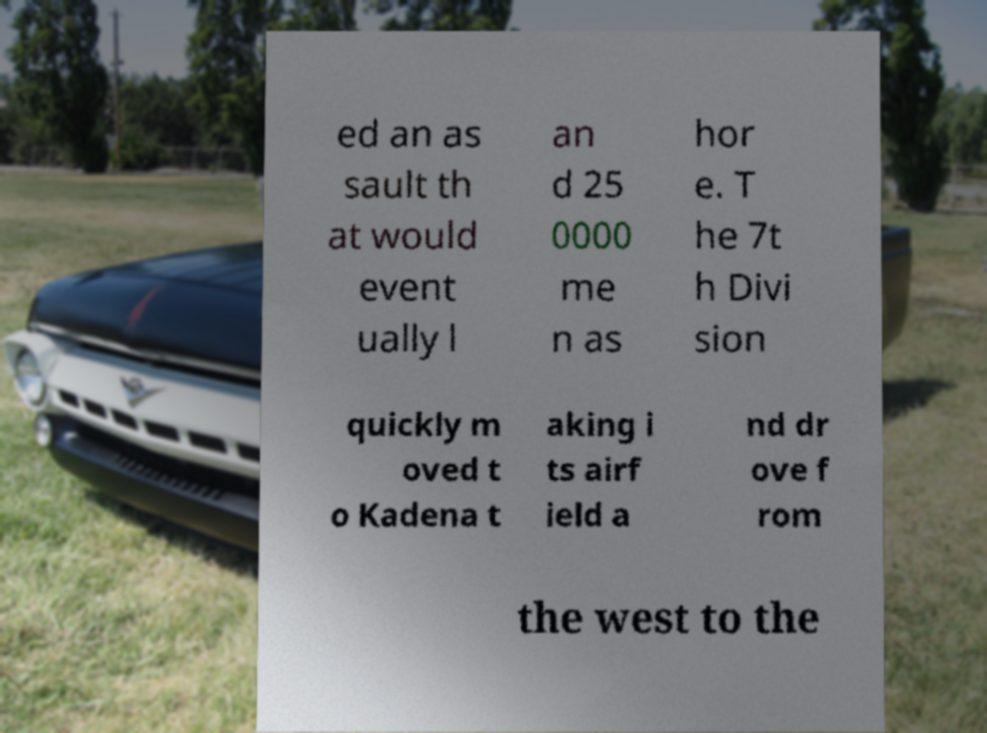Please identify and transcribe the text found in this image. ed an as sault th at would event ually l an d 25 0000 me n as hor e. T he 7t h Divi sion quickly m oved t o Kadena t aking i ts airf ield a nd dr ove f rom the west to the 